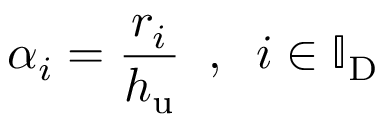<formula> <loc_0><loc_0><loc_500><loc_500>\alpha _ { i } = \frac { r _ { i } } { h _ { u } } \, , \, i \in \mathbb { I } _ { D }</formula> 